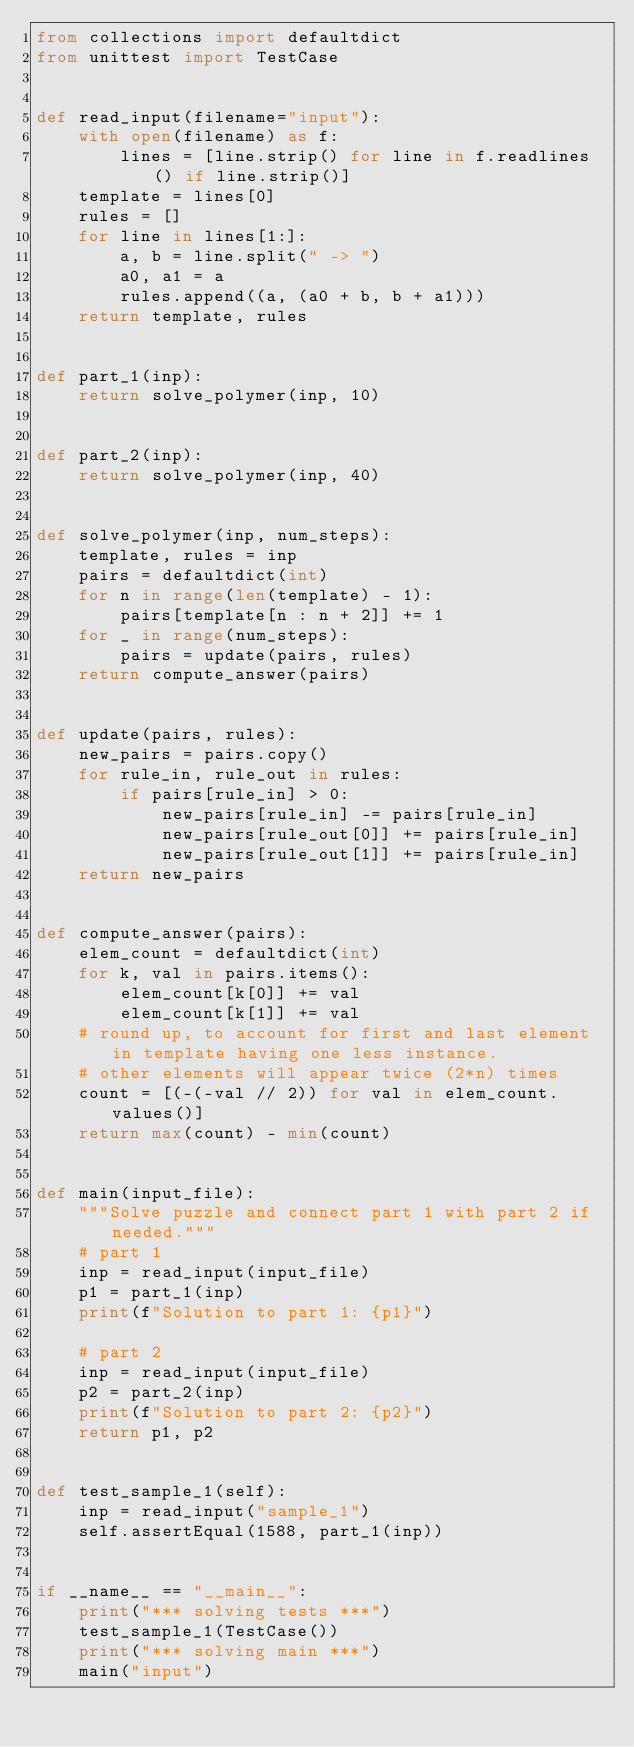Convert code to text. <code><loc_0><loc_0><loc_500><loc_500><_Python_>from collections import defaultdict
from unittest import TestCase


def read_input(filename="input"):
    with open(filename) as f:
        lines = [line.strip() for line in f.readlines() if line.strip()]
    template = lines[0]
    rules = []
    for line in lines[1:]:
        a, b = line.split(" -> ")
        a0, a1 = a
        rules.append((a, (a0 + b, b + a1)))
    return template, rules


def part_1(inp):
    return solve_polymer(inp, 10)


def part_2(inp):
    return solve_polymer(inp, 40)


def solve_polymer(inp, num_steps):
    template, rules = inp
    pairs = defaultdict(int)
    for n in range(len(template) - 1):
        pairs[template[n : n + 2]] += 1
    for _ in range(num_steps):
        pairs = update(pairs, rules)
    return compute_answer(pairs)


def update(pairs, rules):
    new_pairs = pairs.copy()
    for rule_in, rule_out in rules:
        if pairs[rule_in] > 0:
            new_pairs[rule_in] -= pairs[rule_in]
            new_pairs[rule_out[0]] += pairs[rule_in]
            new_pairs[rule_out[1]] += pairs[rule_in]
    return new_pairs


def compute_answer(pairs):
    elem_count = defaultdict(int)
    for k, val in pairs.items():
        elem_count[k[0]] += val
        elem_count[k[1]] += val
    # round up, to account for first and last element in template having one less instance.
    # other elements will appear twice (2*n) times
    count = [(-(-val // 2)) for val in elem_count.values()]
    return max(count) - min(count)


def main(input_file):
    """Solve puzzle and connect part 1 with part 2 if needed."""
    # part 1
    inp = read_input(input_file)
    p1 = part_1(inp)
    print(f"Solution to part 1: {p1}")

    # part 2
    inp = read_input(input_file)
    p2 = part_2(inp)
    print(f"Solution to part 2: {p2}")
    return p1, p2


def test_sample_1(self):
    inp = read_input("sample_1")
    self.assertEqual(1588, part_1(inp))


if __name__ == "__main__":
    print("*** solving tests ***")
    test_sample_1(TestCase())
    print("*** solving main ***")
    main("input")
</code> 